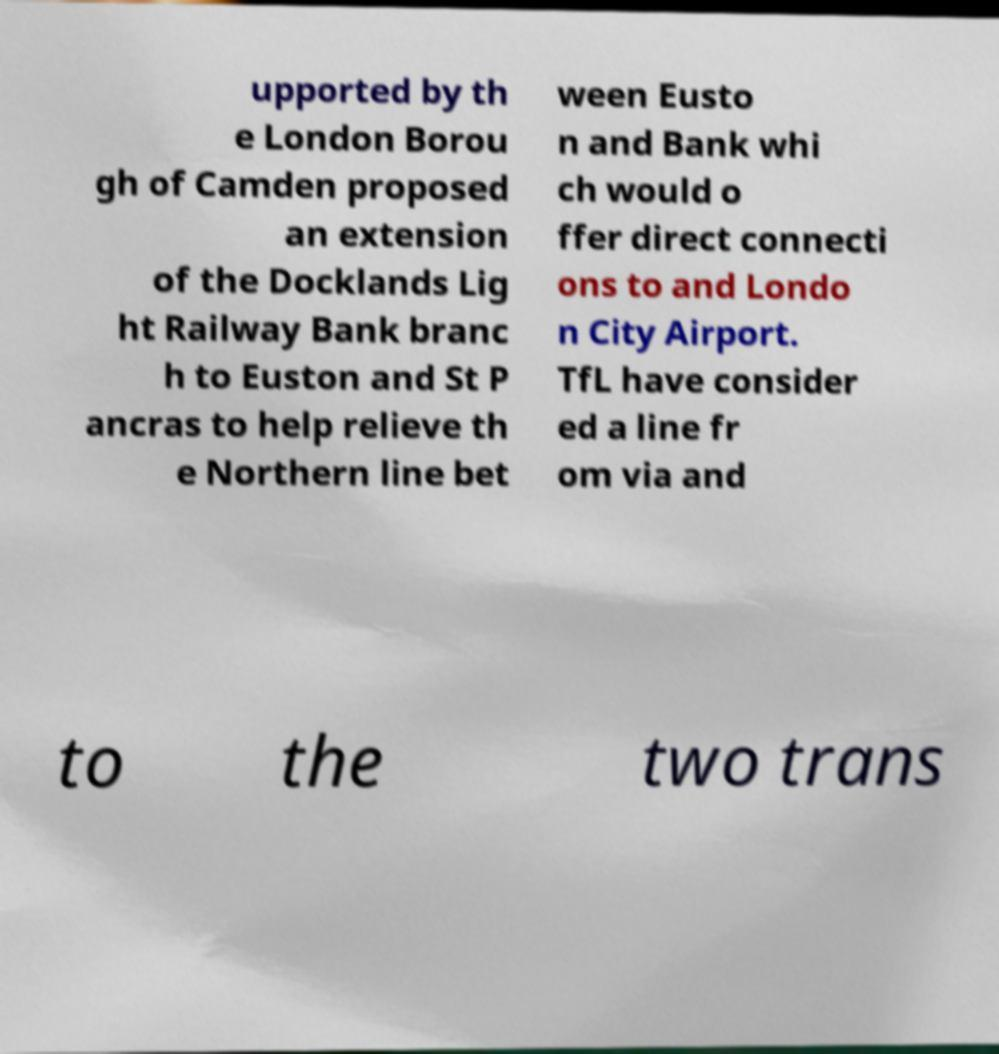Can you read and provide the text displayed in the image?This photo seems to have some interesting text. Can you extract and type it out for me? upported by th e London Borou gh of Camden proposed an extension of the Docklands Lig ht Railway Bank branc h to Euston and St P ancras to help relieve th e Northern line bet ween Eusto n and Bank whi ch would o ffer direct connecti ons to and Londo n City Airport. TfL have consider ed a line fr om via and to the two trans 